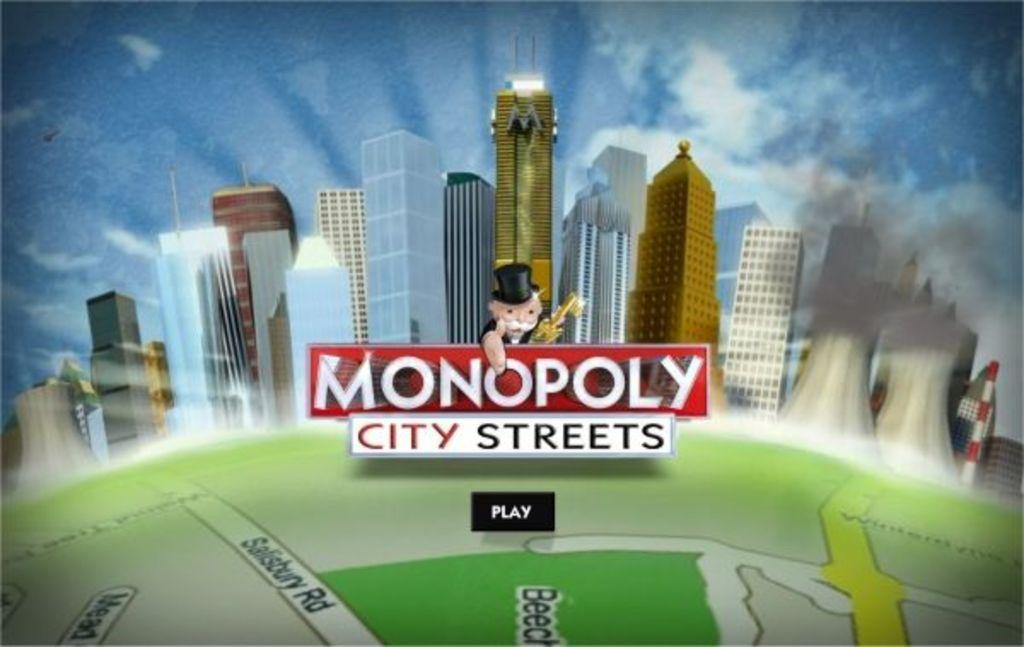<image>
Relay a brief, clear account of the picture shown. Someone is playing a game of Monopoly City Streets. 